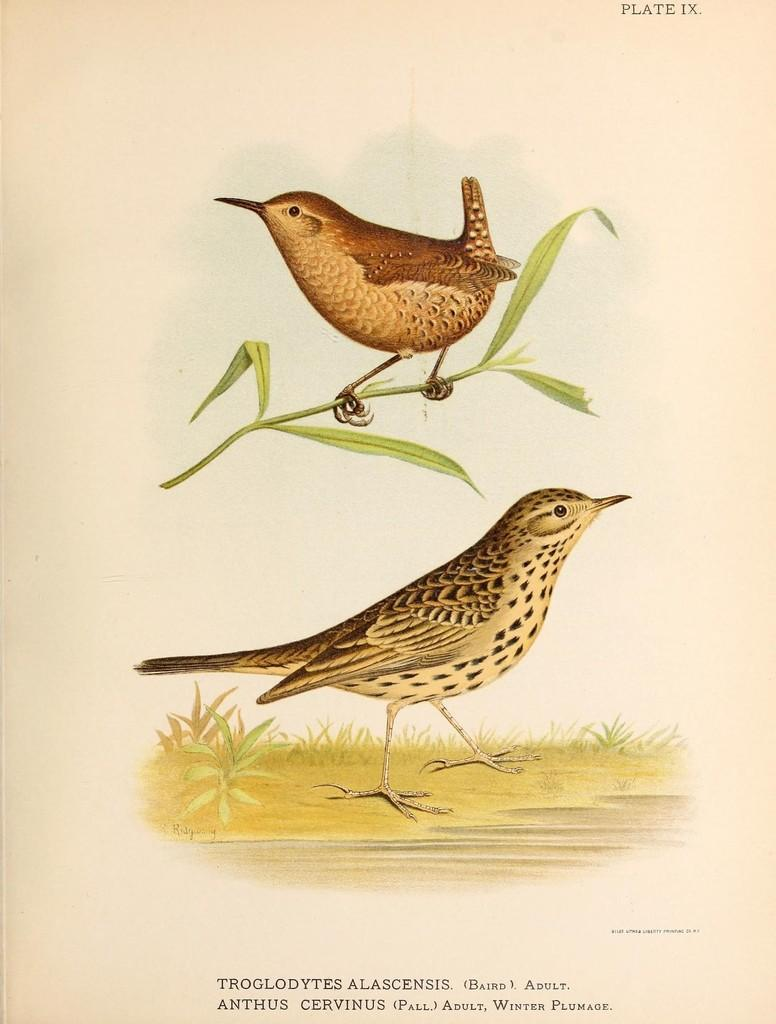What is the main subject of the paper in the image? The paper contains a drawing or image of two birds. What colors are used to depict the birds in the image? The birds are in brown and black colors. What other elements are present in the image besides the birds? There is a stem and green leaves depicted in the image. What type of goat can be seen interacting with the birds in the image? There is no goat present in the image; it only features two birds, a stem, and green leaves. What advice might the grandfather give about the drawing in the image? There is no grandfather present in the image, so it is not possible to determine what advice he might give. 